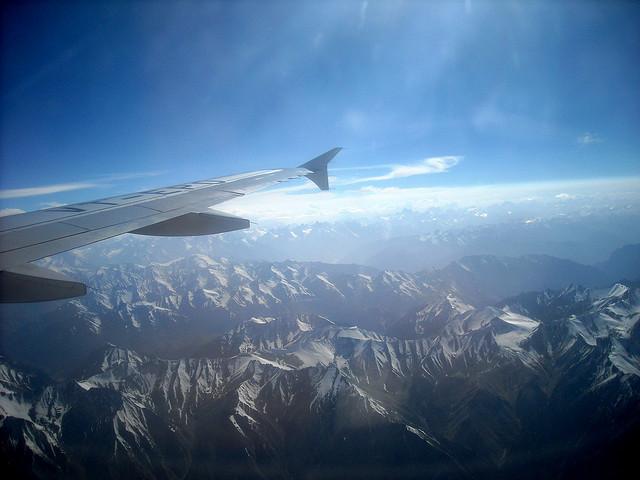What land formations are shown in the image?
Give a very brief answer. Mountains. What type of precipitation is on the top of the mountains?
Concise answer only. Snow. Is the plane flying at a high altitude?
Give a very brief answer. Yes. 